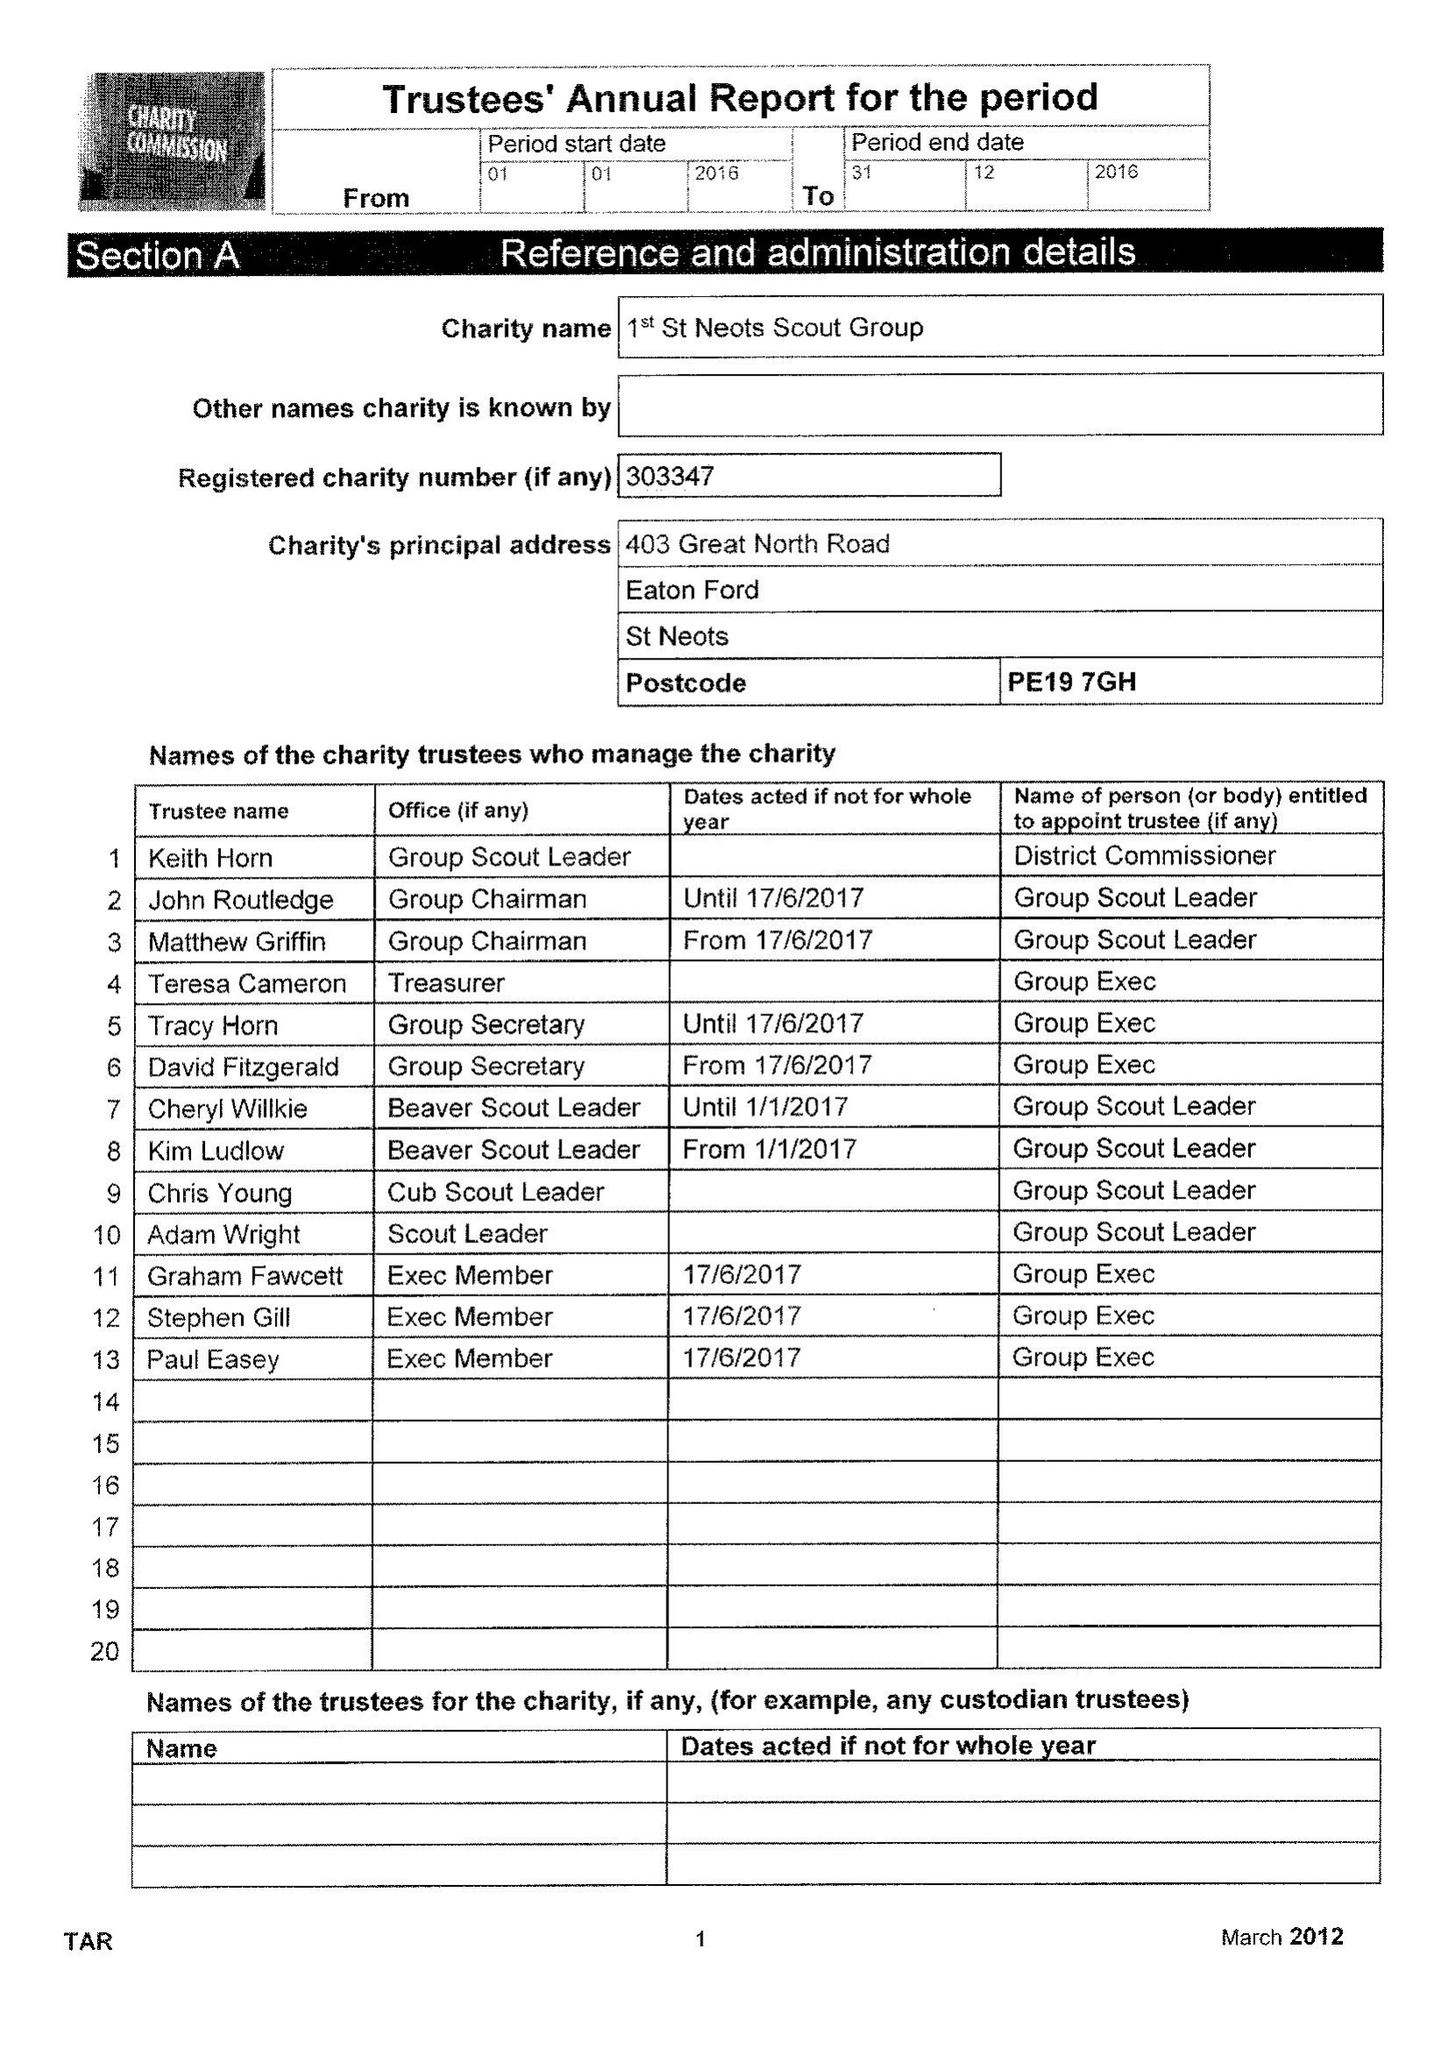What is the value for the address__postcode?
Answer the question using a single word or phrase. PE19 7GH 